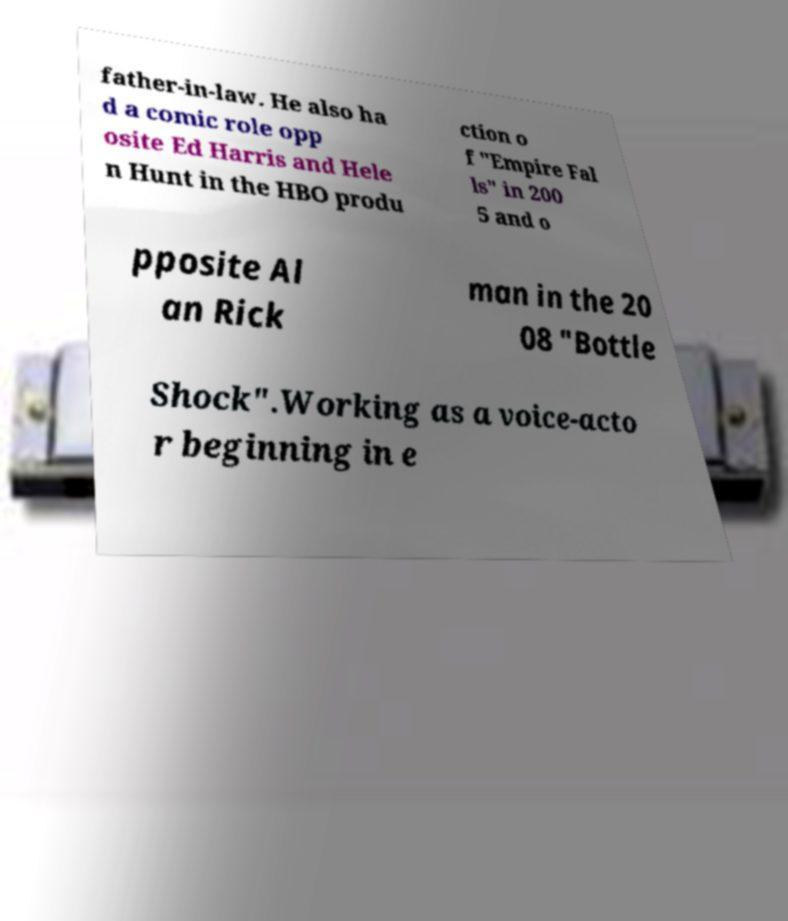For documentation purposes, I need the text within this image transcribed. Could you provide that? father-in-law. He also ha d a comic role opp osite Ed Harris and Hele n Hunt in the HBO produ ction o f "Empire Fal ls" in 200 5 and o pposite Al an Rick man in the 20 08 "Bottle Shock".Working as a voice-acto r beginning in e 